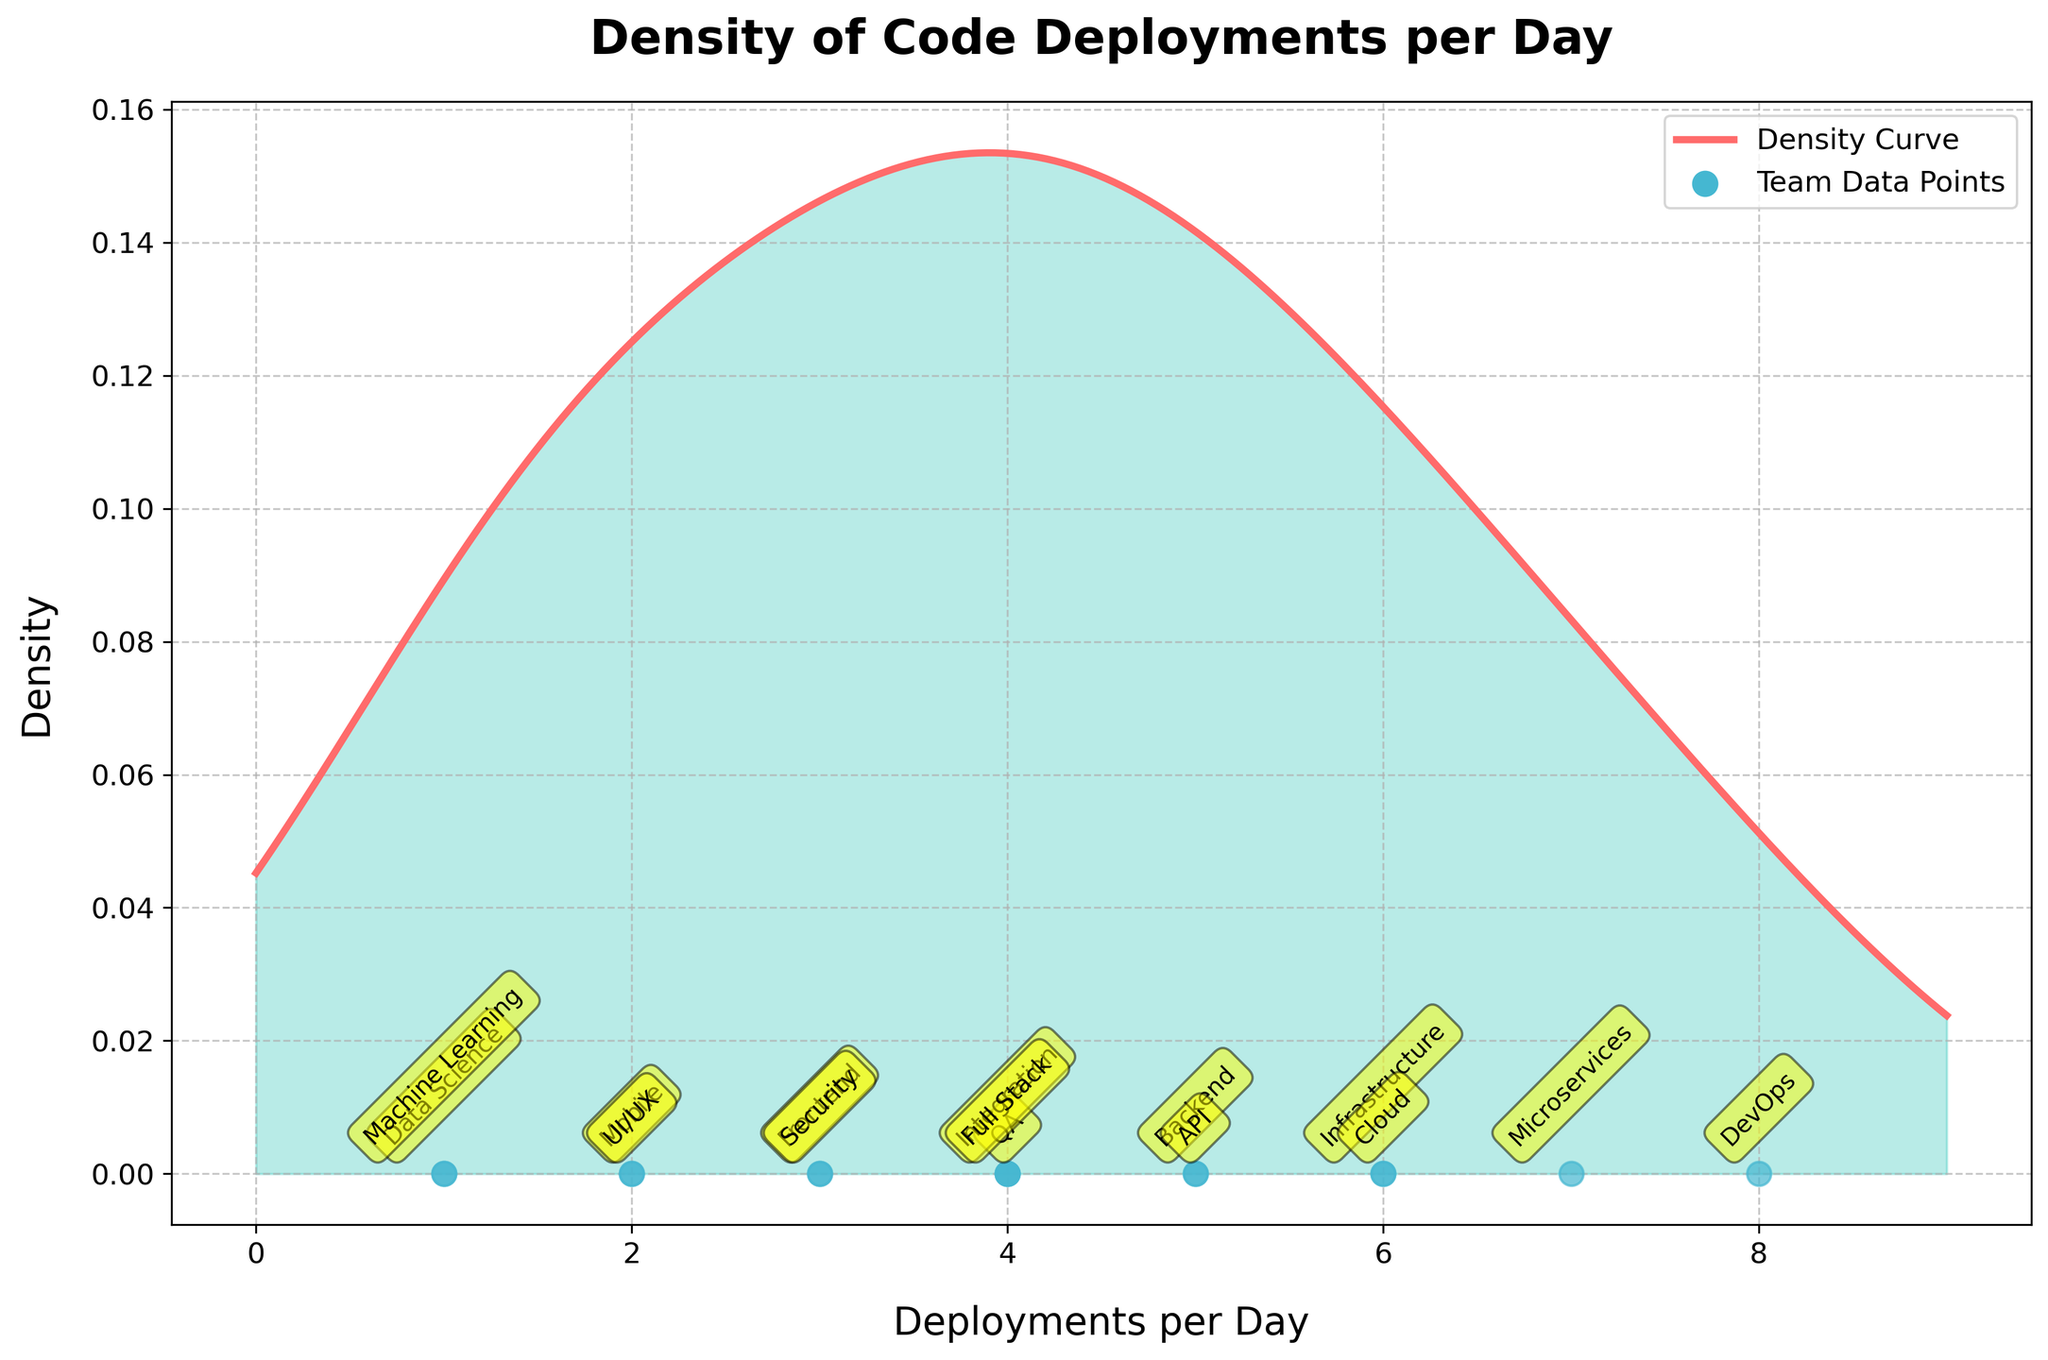What is the title of the plot? The title is located at the top of the figure and is typically the first thing you notice when trying to understand the context of the plot.
Answer: Density of Code Deployments per Day How many teams have their code deployments per day equal to 4? To determine this, locate the data points labeled with teams along the x-axis and count those with a value of 4.
Answer: 3 Which team has the highest number of code deployments per day? To find this, identify the data point with the largest x-value and check the corresponding team label.
Answer: DevOps Between which two data points is the density highest? Observe the density curve and identify the range along the x-axis where the curve reaches its peak to determine between which x-values the highest density occurs.
Answer: Between 4 and 6 Are there any teams with only 1 deployment per day? Check the data points along the x-axis and see if there are any labeled teams with an x-value of 1.
Answer: Yes How many deployments per day does the Integration team have? Locate the data point labeled "Integration" on the x-axis and read its x-value.
Answer: 4 Which team has more deployments: Backend or Security? Compare the x-values of the data points labeled "Backend" and "Security" to see which is larger.
Answer: Backend What's the average number of deployments per day for the teams plotted? Sum all the deployment values and divide by the total number of teams (15 in this case). (3+5+8+2+1+4+2+6+3+4+7+5+6+1+4) / 15
Answer: 4 Which team has the lowest number of code deployments per day? Identify the data point with the smallest x-value and check the team label.
Answer: Data Science and Machine Learning Does the density curve suggest any bimodal distribution? Look at the density curve to check for multiple peaks or modes, indicating whether the distribution is bimodal (two peaks) or not.
Answer: No 